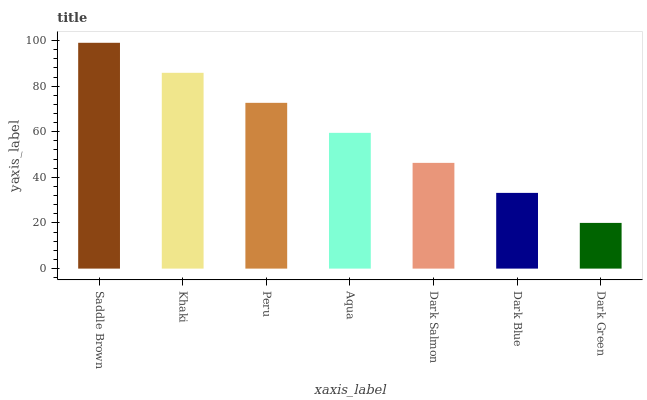Is Dark Green the minimum?
Answer yes or no. Yes. Is Saddle Brown the maximum?
Answer yes or no. Yes. Is Khaki the minimum?
Answer yes or no. No. Is Khaki the maximum?
Answer yes or no. No. Is Saddle Brown greater than Khaki?
Answer yes or no. Yes. Is Khaki less than Saddle Brown?
Answer yes or no. Yes. Is Khaki greater than Saddle Brown?
Answer yes or no. No. Is Saddle Brown less than Khaki?
Answer yes or no. No. Is Aqua the high median?
Answer yes or no. Yes. Is Aqua the low median?
Answer yes or no. Yes. Is Saddle Brown the high median?
Answer yes or no. No. Is Dark Salmon the low median?
Answer yes or no. No. 